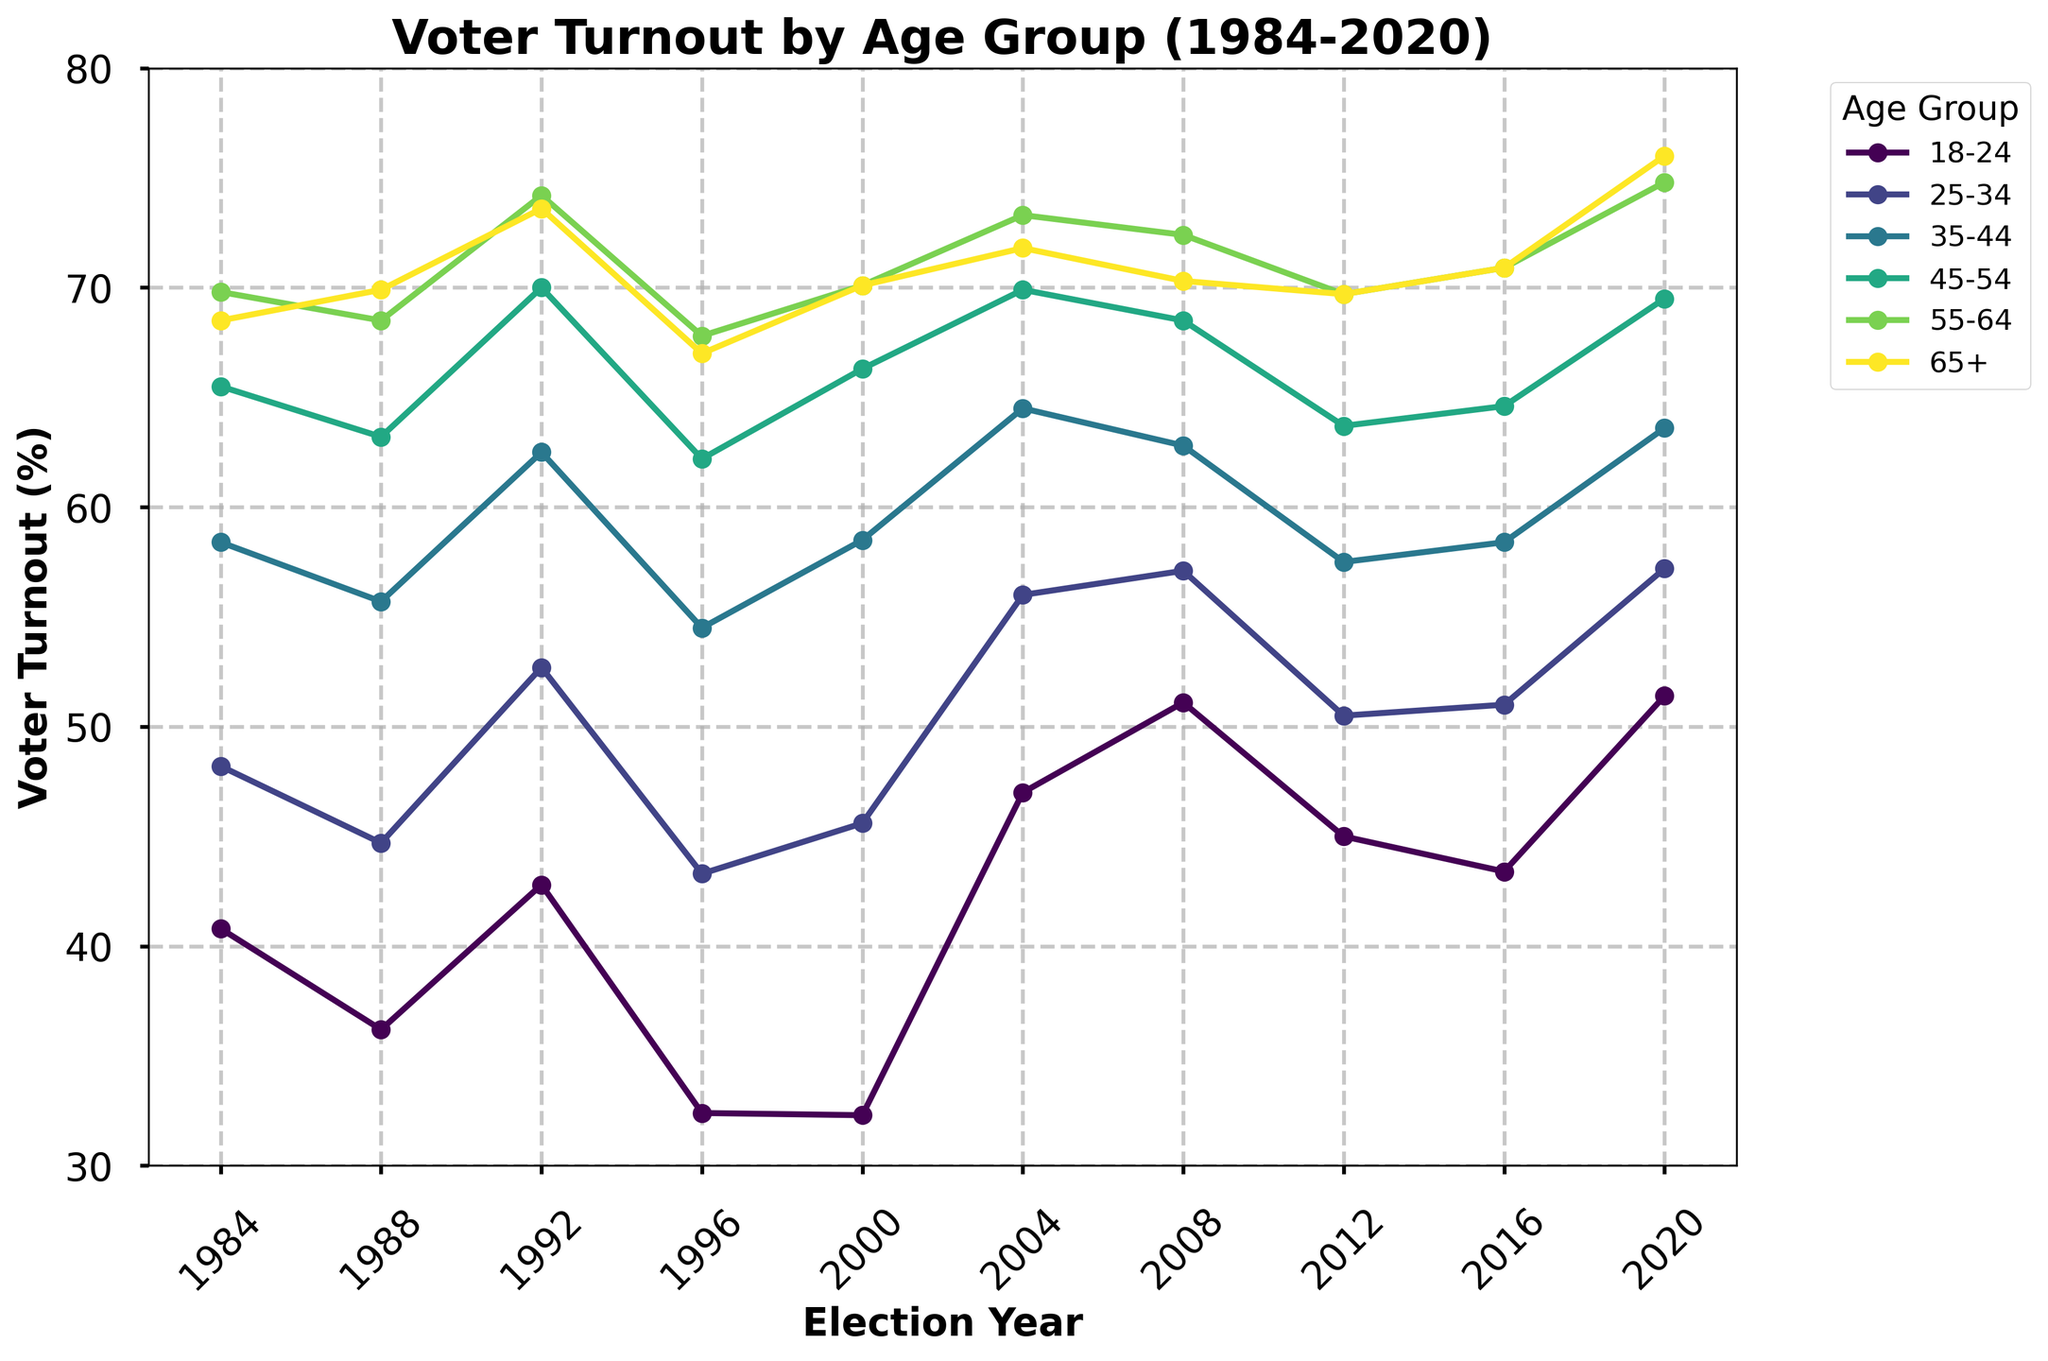What was the voter turnout percentage for the age group 18-24 in the 2020 election? Look at the point corresponding to the year 2020 along the line representing the 18-24 age group.
Answer: 51.4 Which age group had the highest voter turnout in 2020? Identify the line with the highest point in the year 2020.
Answer: 65+ By how much did the voter turnout percentage for the age group 25-34 increase from the 1996 to the 2004 election? Subtract the turnout in 1996 from the turnout in 2004 for the age group 25-34. 56.0 - 43.3 = 12.7
Answer: 12.7 Did the age group 45-54 have a higher voter turnout percentage in 1992 or 2012? Compare the height of the points for the years 1992 and 2012 on the 45-54 age group line.
Answer: 1992 Which two consecutive elections showed the largest increase in voter turnout percentage for the age group 18-24? Identify the two consecutive points between which the vertical distance covered is biggest on the 18-24 line. The largest difference is between 2000 (32.3%) and 2004 (47.0%).
Answer: 2000 to 2004 What was the average voter turnout percentage for the age group 65+ over the last 10 presidential elections? Add the percentages of the 65+ age group for each year and divide by the number of years (10). (68.5 + 69.9 + 73.6 + 67.0 + 70.1 + 71.8 + 70.3 + 69.7 + 70.9 + 76.0) / 10 = 70.78
Answer: 70.78 Which age group showed a decline in voter turnout percentage between 1984 and 1988? Compare the voter turnout percentages for each age group between 1984 and 1988 and identify any group that has a lower percentage in 1988 than in 1984. Only the 18-24 age group shows a decline from 40.8 to 36.2.
Answer: 18-24 Between the elections of 1992 and 2020, which age group showed the most consistent voter turnout (least fluctuation)? Observe the smoothness or consistency in the line graphs between 1992 and 2020 for each age group by visual inspection. The 65+ age group shows minimal fluctuation.
Answer: 65+ What is the difference in voter turnout percentage between the age group 55-64 and 35-44 in the 2020 election? Subtract the turnout percentage for the age group 35-44 from that of 55-64 in the 2020 election. 74.8 - 63.6 = 11.2
Answer: 11.2 